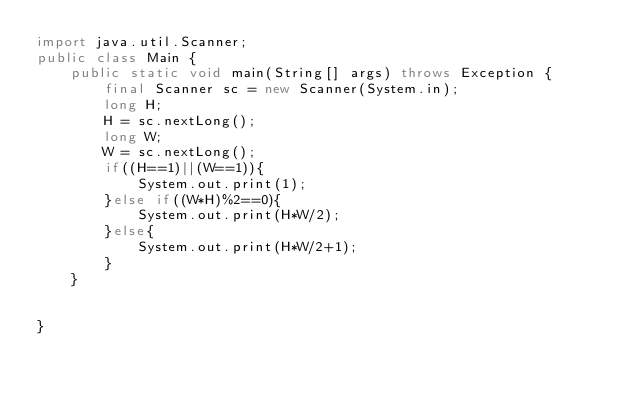<code> <loc_0><loc_0><loc_500><loc_500><_Java_>import java.util.Scanner;
public class Main {
    public static void main(String[] args) throws Exception {
        final Scanner sc = new Scanner(System.in);
        long H;
        H = sc.nextLong();
        long W;
        W = sc.nextLong();
        if((H==1)||(W==1)){
            System.out.print(1);
        }else if((W*H)%2==0){
            System.out.print(H*W/2);
        }else{
            System.out.print(H*W/2+1);
        }  
    }

    
}</code> 